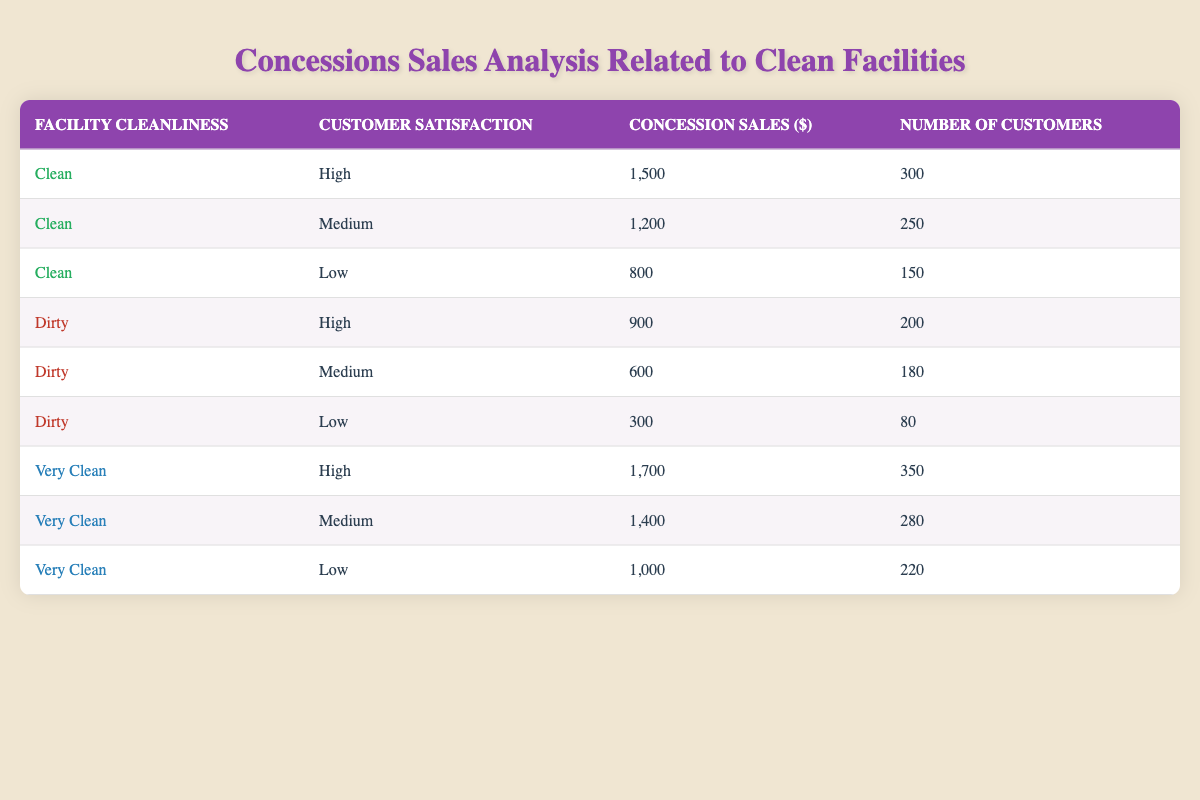What are the concession sales for the “Very Clean” facilities with high customer satisfaction? By looking at the row for "Very Clean" and "High" customer satisfaction, the concession sales amount is listed as 1700.
Answer: 1700 What is the total number of customers for all Dirty facility scenarios? To find the total, we add the number of customers from each "Dirty" row: 200 (High) + 180 (Medium) + 80 (Low) = 460.
Answer: 460 Is customer satisfaction high for any “Clean” facility? Checking the rows for "Clean", the satisfaction level "High" has a corresponding value, indicating that there is indeed a case where satisfaction is high.
Answer: Yes How much higher are concession sales in “Very Clean” facilities with high satisfaction compared to those with low satisfaction? The sales for "Very Clean" with high satisfaction is 1700, and for low satisfaction, it is 1000. The difference is calculated as 1700 - 1000 = 700.
Answer: 700 What is the average number of customers for all the “Clean” facility scenarios? For "Clean", we have 300 (High), 250 (Medium), and 150 (Low). The total number of customers is 300 + 250 + 150 = 700. The average is then calculated by dividing the total by the number of scenarios: 700 / 3 = approximately 233.33.
Answer: Approximately 233.33 Do any “Dirty” facilities show concession sales exceeding 600? Observing the "Dirty" rows, only the High setting has 900, and the Medium has 600; hence, we have cases that do exceed 600.
Answer: Yes Which facility cleanliness has the highest number of customers, and how many is that? Looking at the data, "Very Clean" has the highest number of customers at 350 under "High" satisfaction, which is greater than any other cleanliness category.
Answer: 350 How much total concession sales do the “Clean” and “Very Clean” facilities generate when customer satisfaction is Medium? For "Clean" with Medium satisfaction, sales are 1200, and for "Very Clean" with Medium satisfaction, sales are 1400. Adding these gives 1200 + 1400 = 2600.
Answer: 2600 